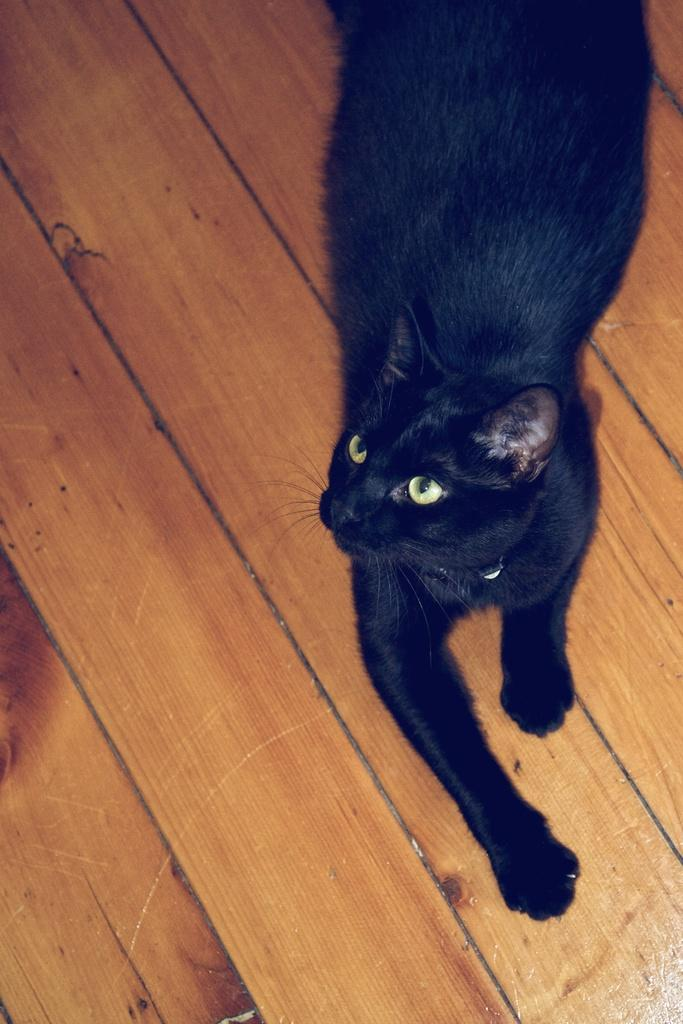What type of animal is in the image? There is a black cat in the image. What position is the cat in? The cat is lying on the floor. What material is the floor made of? The floor is made of wood. What is the cat holding in its paw? There is no mention of the cat holding anything in its paw in the provided facts. 